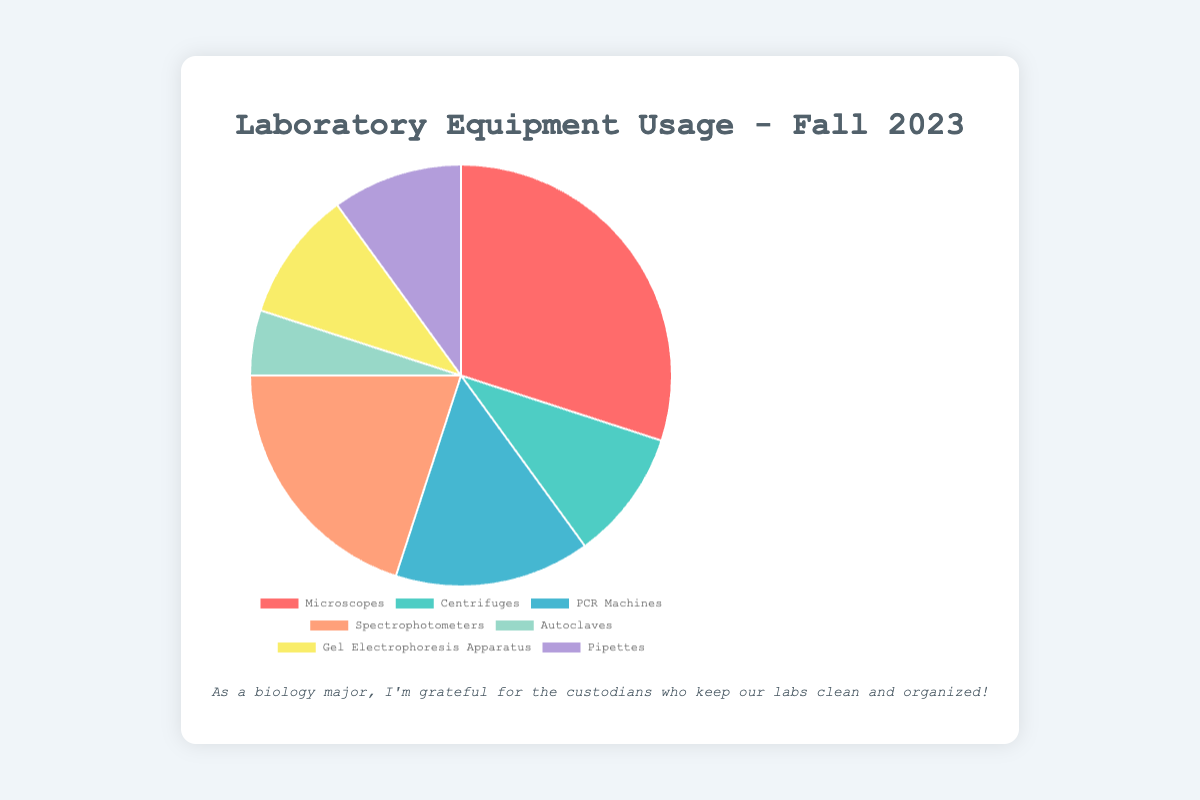Which laboratory equipment has the highest usage percentage? According to the chart, the proportions of different laboratory equipment usages are visually represented. The largest segment corresponds to the Microscopes category.
Answer: Microscopes How much more is the usage percentage of Spectrophotometers compared to Autoclaves? The usage percentage for Spectrophotometers is 20%, and for Autoclaves, it is 5%. The difference between them is calculated by subtracting 5 from 20.
Answer: 15% What is the total usage percentage of Centrifuges and Pipettes combined? The percentage usage of Centrifuges is 10% and Pipettes is also 10%. Adding these together gives us the total percentage.
Answer: 20% Which two equipment types have equal usage percentages? The chart indicates the segments for Centrifuges and Pipettes, both of which occupy equal-sized portions of the pie chart, representing the same percentage.
Answer: Centrifuges and Pipettes What is the combined usage percentage of Gel Electrophoresis Apparatus and PCR Machines? The usage percentage of Gel Electrophoresis Apparatus is 10%, and for PCR Machines, it is 15%. Adding these together gives the total percentage.
Answer: 25% List the equipment that have a usage percentage greater than 10%. From the chart, the categories with more than 10% usage are Microscopes (30%), Spectrophotometers (20%), and PCR Machines (15%).
Answer: Microscopes, Spectrophotometers, PCR Machines Which equipment segment is represented by the color red? Red represents the segment of Microscopes; it is the largest segment on the chart as indicated by the color coding.
Answer: Microscopes What is the average usage percentage of all the equipment? To find the average, sum the usage percentages of all equipment: 30 + 10 + 15 + 20 + 5 + 10 + 10 = 100. There are 7 pieces of equipment, so the average is 100/7.
Answer: Approximately 14.29% How does the usage of PCR Machines compare to the usage of Centrifuges? The PCR Machines have a usage percentage of 15%, while Centrifuges have 10%. Therefore, PCR Machines are used more than Centrifuges by subtracting 10 from 15.
Answer: 5% more By how much does the usage of Microscopes exceed the combined usage of Autoclaves and Gel Electrophoresis Apparatus? Summing the usage percentages of Autoclaves (5%) and Gel Electrophoresis Apparatus (10%) gives 15%. The usage percentage of Microscopes is 30%, so we subtract 15 from 30.
Answer: 15% 